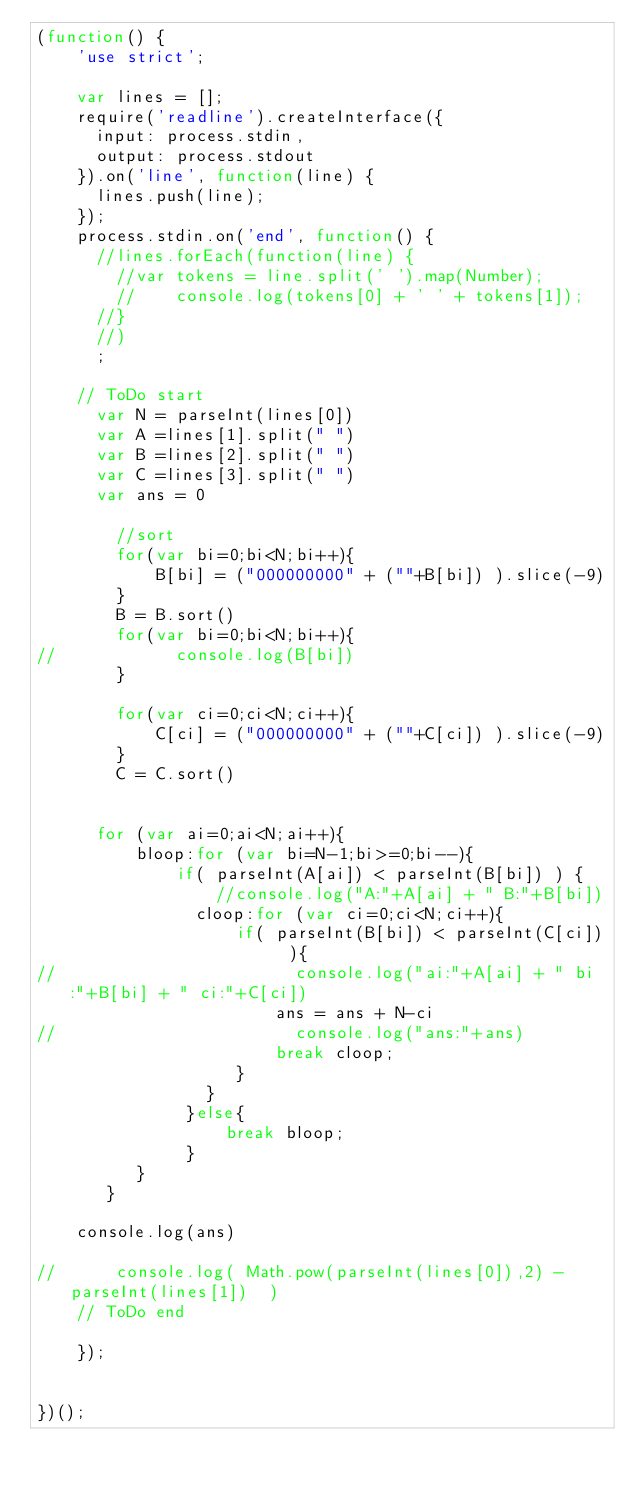Convert code to text. <code><loc_0><loc_0><loc_500><loc_500><_JavaScript_>(function() {
    'use strict';

    var lines = [];
    require('readline').createInterface({
      input: process.stdin,
      output: process.stdout
    }).on('line', function(line) {
      lines.push(line);
    });
    process.stdin.on('end', function() {
      //lines.forEach(function(line) {
        //var tokens = line.split(' ').map(Number);
        //    console.log(tokens[0] + ' ' + tokens[1]);
      //}
      //)
      ;

    // ToDo start
      var N = parseInt(lines[0])
      var A =lines[1].split(" ")
      var B =lines[2].split(" ")
      var C =lines[3].split(" ")
      var ans = 0

        //sort
        for(var bi=0;bi<N;bi++){
            B[bi] = ("000000000" + (""+B[bi]) ).slice(-9)
        }
        B = B.sort()
        for(var bi=0;bi<N;bi++){
//            console.log(B[bi])
        }
        
        for(var ci=0;ci<N;ci++){
            C[ci] = ("000000000" + (""+C[ci]) ).slice(-9)
        }
        C = C.sort()
        

      for (var ai=0;ai<N;ai++){
          bloop:for (var bi=N-1;bi>=0;bi--){
              if( parseInt(A[ai]) < parseInt(B[bi]) ) {
                  //console.log("A:"+A[ai] + " B:"+B[bi])
                cloop:for (var ci=0;ci<N;ci++){
                    if( parseInt(B[bi]) < parseInt(C[ci])  ){
//                        console.log("ai:"+A[ai] + " bi:"+B[bi] + " ci:"+C[ci])
                        ans = ans + N-ci
//                        console.log("ans:"+ans)
                        break cloop;
                    }
                 }
               }else{
                   break bloop;
               }
          }
       }

    console.log(ans)
      
//      console.log( Math.pow(parseInt(lines[0]),2) - parseInt(lines[1])  )
    // ToDo end

    });


})();

</code> 